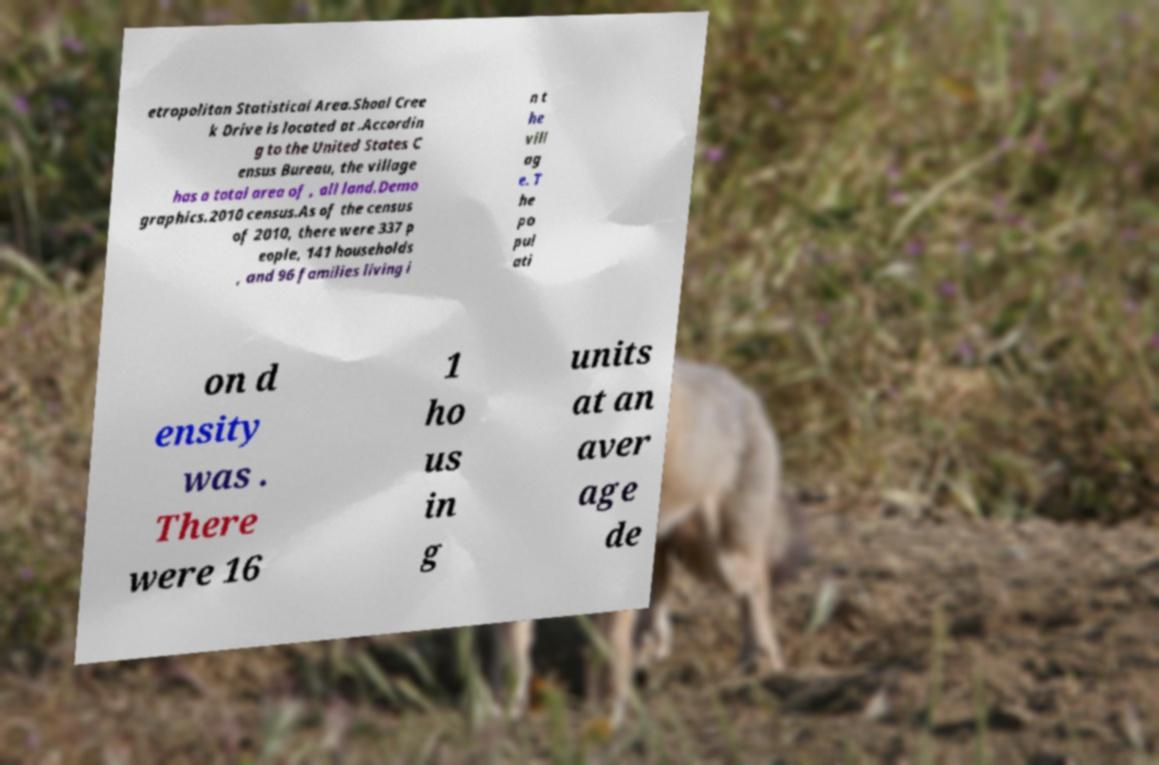Can you read and provide the text displayed in the image?This photo seems to have some interesting text. Can you extract and type it out for me? etropolitan Statistical Area.Shoal Cree k Drive is located at .Accordin g to the United States C ensus Bureau, the village has a total area of , all land.Demo graphics.2010 census.As of the census of 2010, there were 337 p eople, 141 households , and 96 families living i n t he vill ag e. T he po pul ati on d ensity was . There were 16 1 ho us in g units at an aver age de 